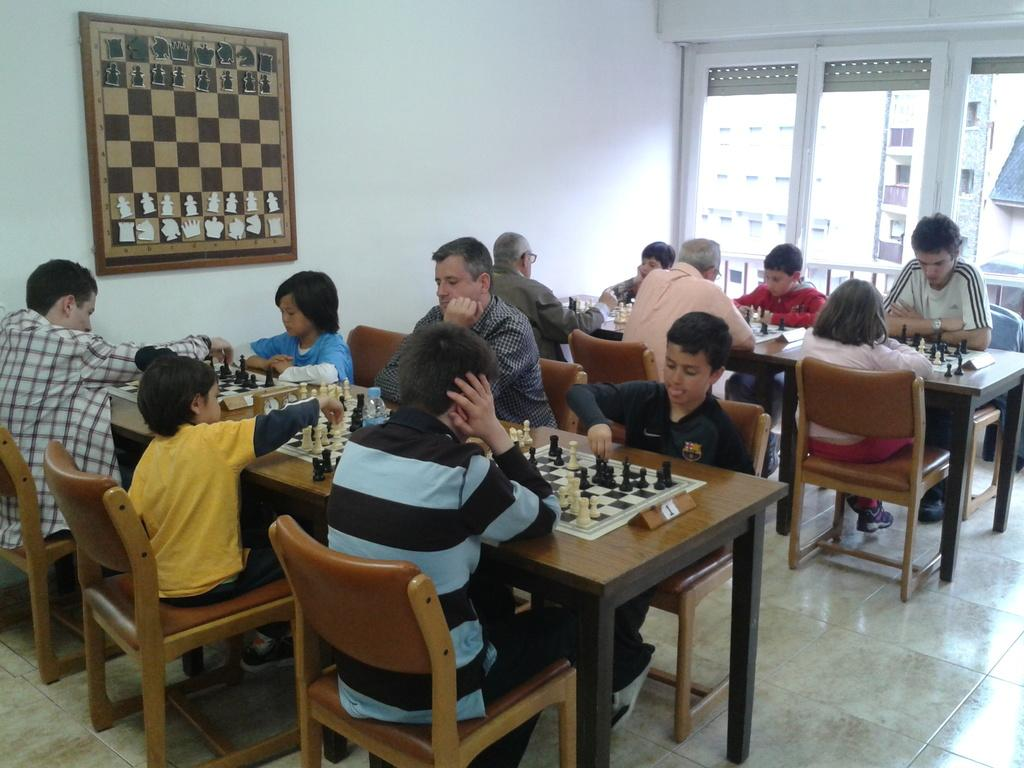What are the persons in the image doing? The persons in the image are sitting on chairs. What can be seen on the table in the image? There are chess boards and coins on the table. What is depicted on the wall in the image? There is a chess board picture on the wall. What is the source of natural light in the room? There is a window in the room. What can be seen outside the window? Buildings are visible through the window. What type of poison is being discussed by the persons in the image? There is no discussion about poison in the image; the persons are playing chess. Is there a coat visible on any of the persons in the image? There is no coat visible on any of the persons in the image. 